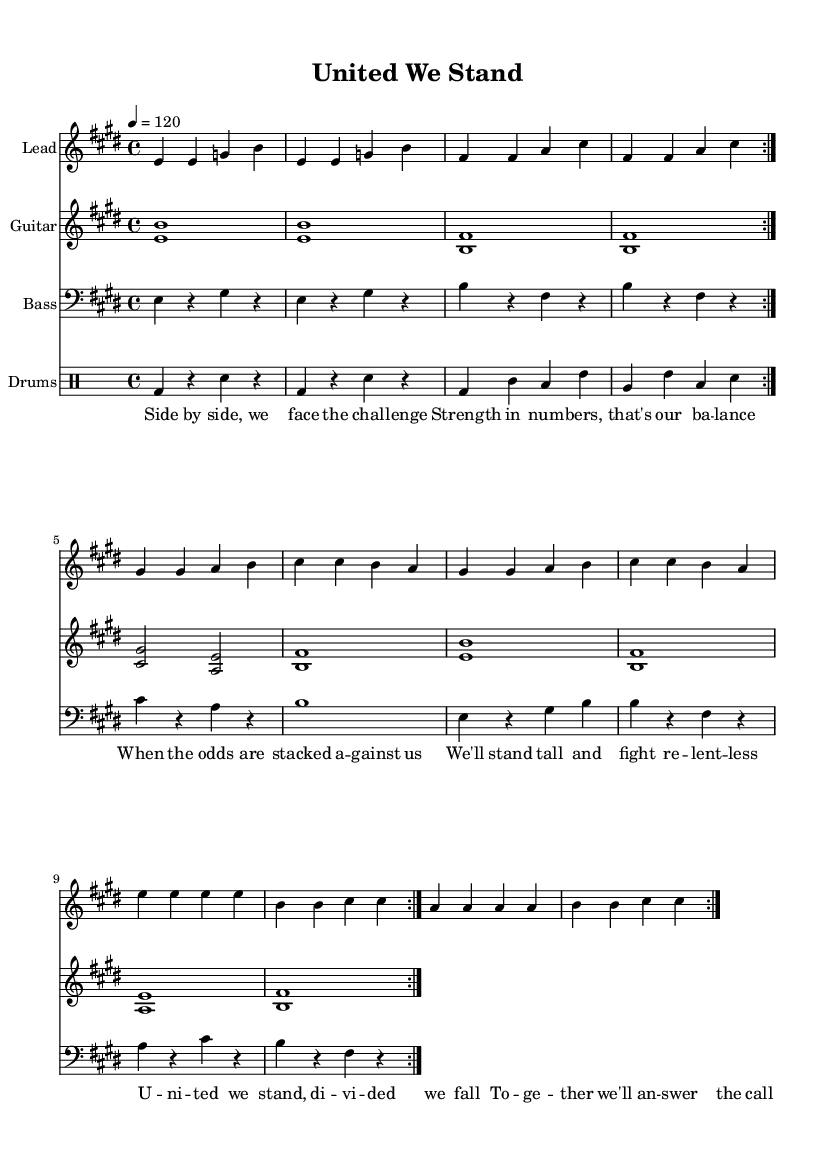What is the key signature of this music? The key signature shown is E major, which has four sharps. You can identify this by looking at the key signature at the beginning of the staff.
Answer: E major What is the time signature of this music? The time signature is 4/4, indicated at the start of the score. It signifies that there are four beats in each measure and the quarter note gets the beat.
Answer: 4/4 What is the tempo of this music? The tempo is indicated as 120 beats per minute with the marking "4 = 120." This means that one quarter note equals 120 beats per minute.
Answer: 120 How many measures are repeated in the melody section? The melody contains a repeat sign that indicates the section should be played twice. This can be determined by observing the repeat markings present in the melody.
Answer: 2 What instruments are included in this score? The score contains four distinct instruments: Lead, Guitar, Bass, and Drums. Each is indicated in the staff labels provided.
Answer: Lead, Guitar, Bass, Drums How many lines are in the melodic staff? The melodic staff typically consists of five lines, aligning with the standard notation principles. You can count the lines present in the staff of the melody part to confirm this.
Answer: 5 